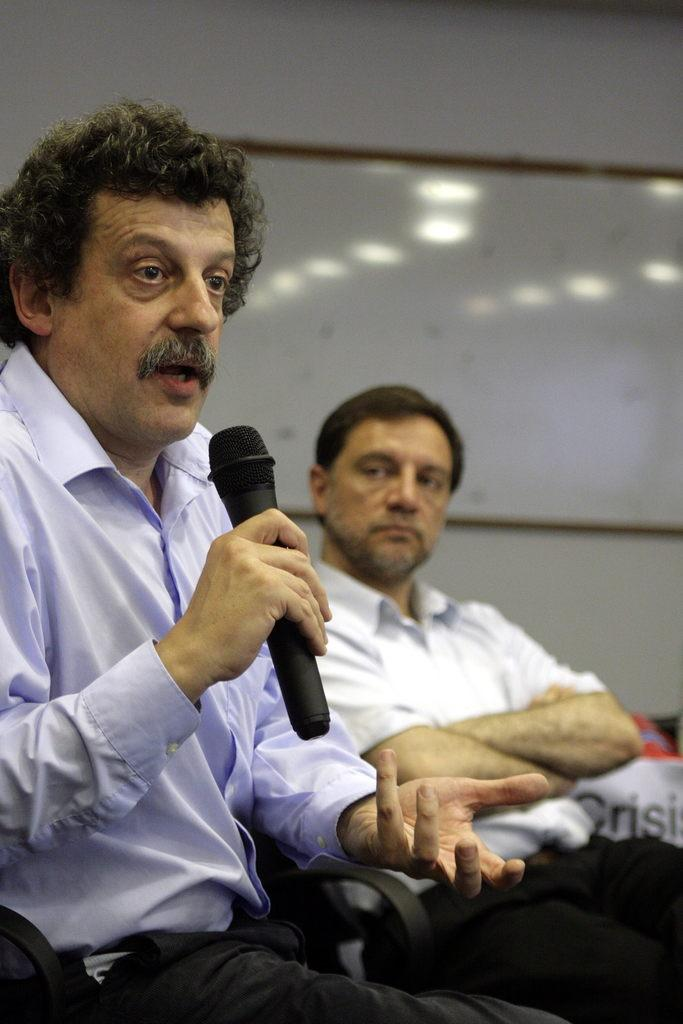What is the main activity of the person in the image? The person in the image is sitting and speaking in front of a mic. Is there anyone else present in the image? Yes, there is another person sitting beside the first person. What is the color of the background in the image? The background of the image is white in color. How many frogs can be seen sitting on the dolls in the image? There are no frogs or dolls present in the image. What type of fork is being used by the person in the image? There is no fork visible in the image. 